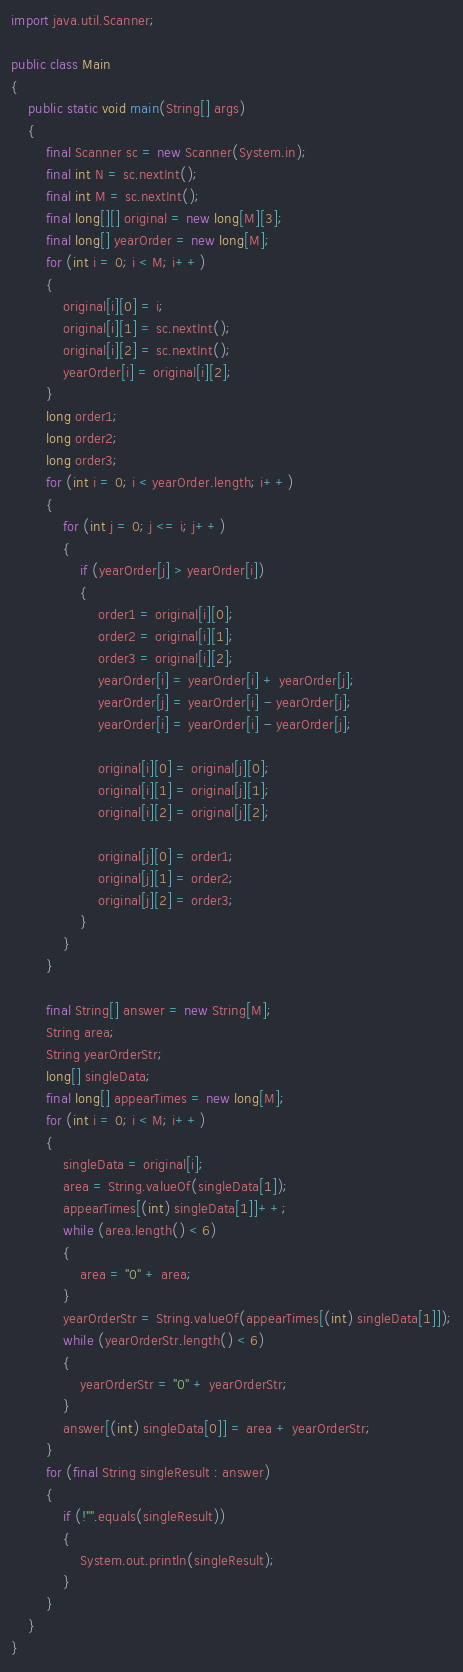<code> <loc_0><loc_0><loc_500><loc_500><_Java_>import java.util.Scanner;

public class Main
{
    public static void main(String[] args)
    {
        final Scanner sc = new Scanner(System.in);
        final int N = sc.nextInt();
        final int M = sc.nextInt();
        final long[][] original = new long[M][3];
        final long[] yearOrder = new long[M];
        for (int i = 0; i < M; i++)
        {
            original[i][0] = i;
            original[i][1] = sc.nextInt();
            original[i][2] = sc.nextInt();
            yearOrder[i] = original[i][2];
        }
        long order1;
        long order2;
        long order3;
        for (int i = 0; i < yearOrder.length; i++)
        {
            for (int j = 0; j <= i; j++)
            {
                if (yearOrder[j] > yearOrder[i])
                {
                    order1 = original[i][0];
                    order2 = original[i][1];
                    order3 = original[i][2];
                    yearOrder[i] = yearOrder[i] + yearOrder[j];
                    yearOrder[j] = yearOrder[i] - yearOrder[j];
                    yearOrder[i] = yearOrder[i] - yearOrder[j];

                    original[i][0] = original[j][0];
                    original[i][1] = original[j][1];
                    original[i][2] = original[j][2];

                    original[j][0] = order1;
                    original[j][1] = order2;
                    original[j][2] = order3;
                }
            }
        }

        final String[] answer = new String[M];
        String area;
        String yearOrderStr;
        long[] singleData;
        final long[] appearTimes = new long[M];
        for (int i = 0; i < M; i++)
        {
            singleData = original[i];
            area = String.valueOf(singleData[1]);
            appearTimes[(int) singleData[1]]++;
            while (area.length() < 6)
            {
                area = "0" + area;
            }
            yearOrderStr = String.valueOf(appearTimes[(int) singleData[1]]);
            while (yearOrderStr.length() < 6)
            {
                yearOrderStr = "0" + yearOrderStr;
            }
            answer[(int) singleData[0]] = area + yearOrderStr;
        }
        for (final String singleResult : answer)
        {
            if (!"".equals(singleResult))
            {
                System.out.println(singleResult);
            }
        }
    }
}
</code> 